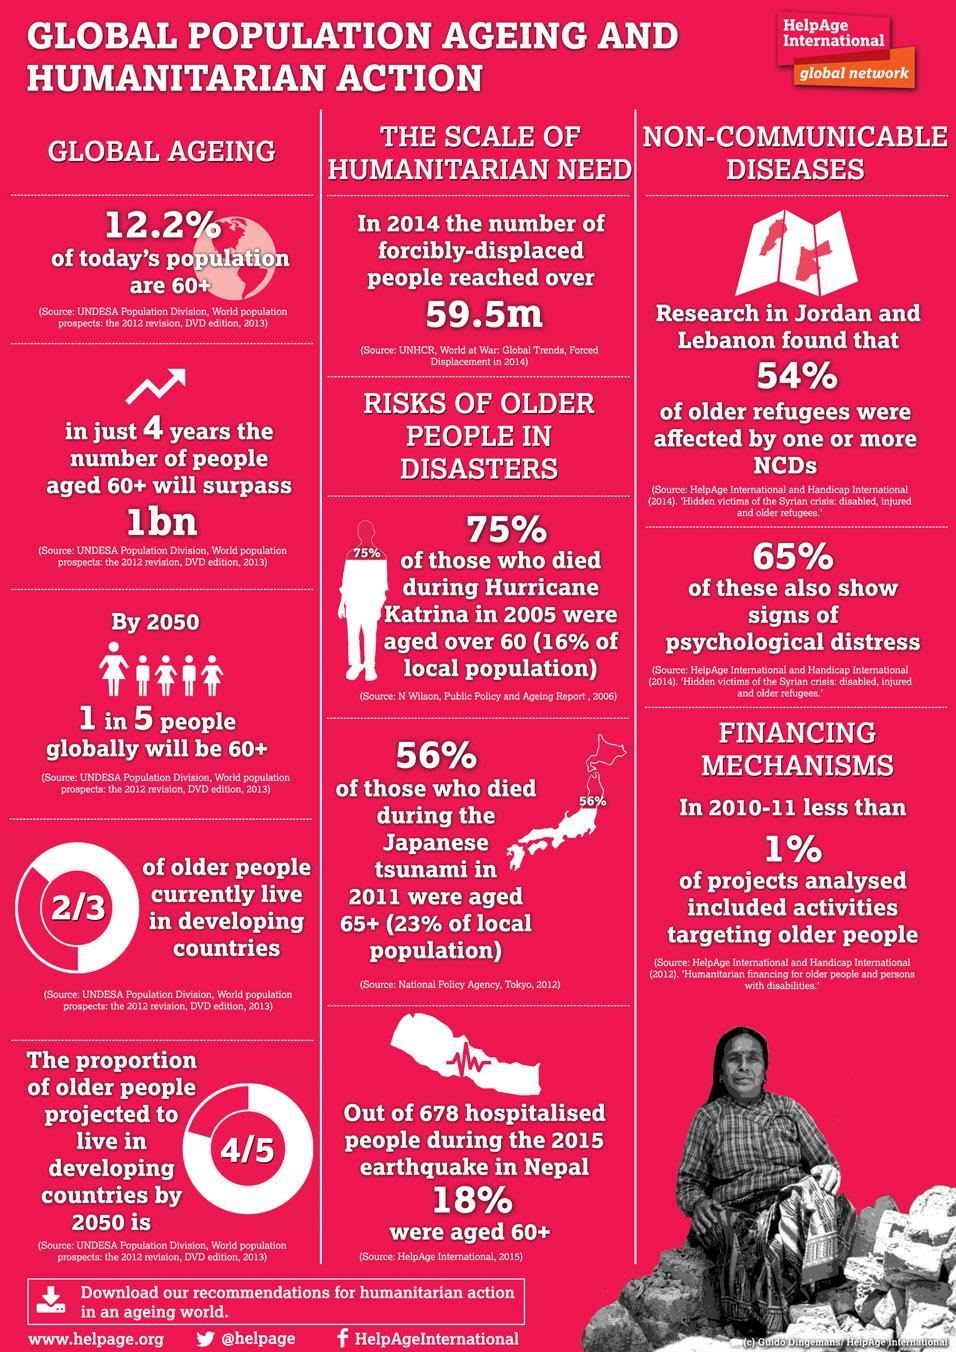What is the projected ratio of senior citizens in the year 2050, 1:5, 4:5, or 2:3?
Answer the question with a short phrase. 4:5 